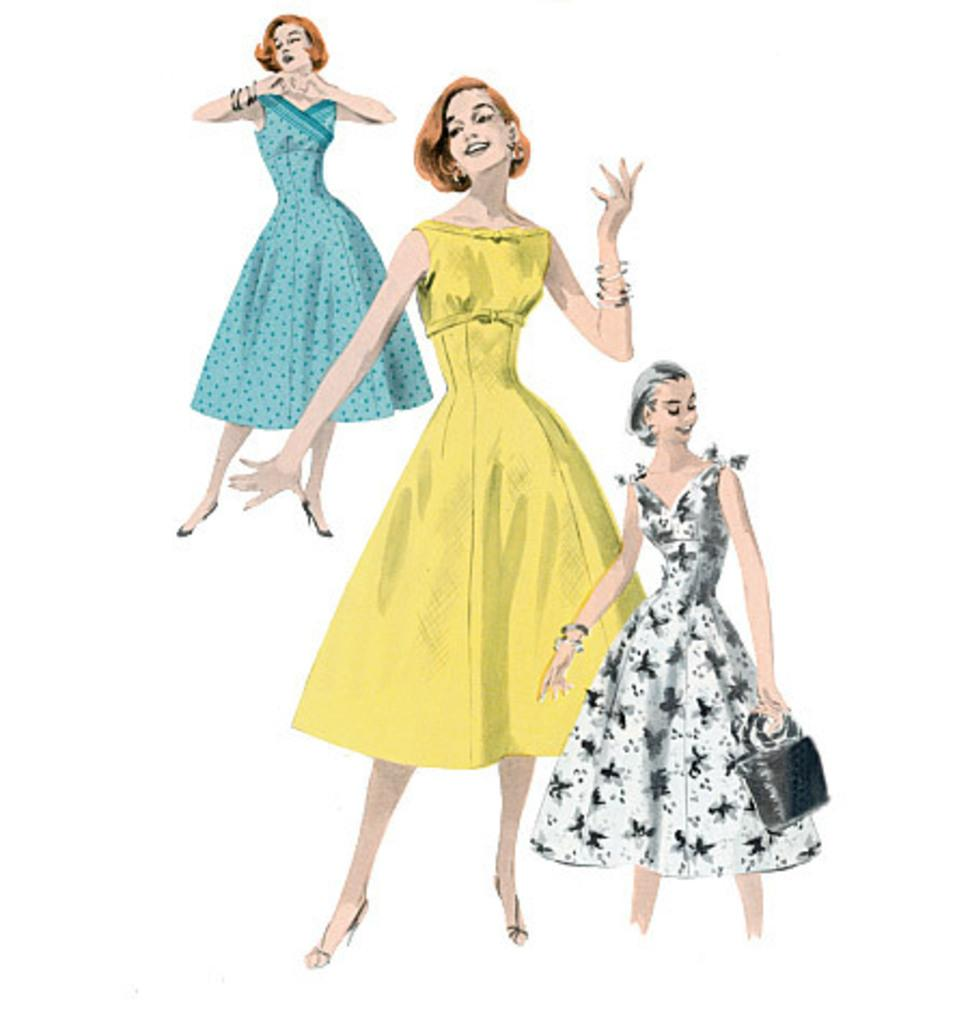What is depicted in the paintings in the image? There are paintings of three women in the image. What are the women doing in the paintings? The women are standing in the paintings. What expressions do the women have in the paintings? The women are smiling in the paintings. What is the color of the surface on which the paintings are displayed? The paintings are on a white color surface. What is the color of the background in the paintings? The background of the paintings is white in color. What type of yarn is being used to create the paintings in the image? There is no yarn present in the image; the paintings are created using a different medium, likely paint. Can you see any blood on the women in the paintings? There is no blood visible on the women in the paintings; they are smiling and appear to be in a peaceful setting. 